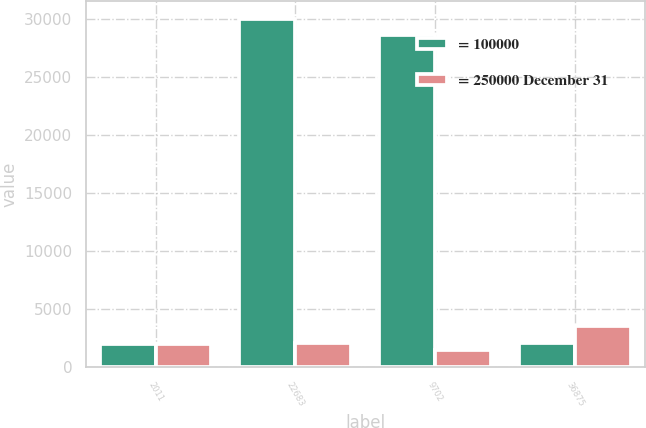Convert chart. <chart><loc_0><loc_0><loc_500><loc_500><stacked_bar_chart><ecel><fcel>2011<fcel>22683<fcel>9702<fcel>36875<nl><fcel>= 100000<fcel>2010<fcel>30007<fcel>28584<fcel>2105<nl><fcel>= 250000 December 31<fcel>2011<fcel>2105<fcel>1450<fcel>3555<nl></chart> 